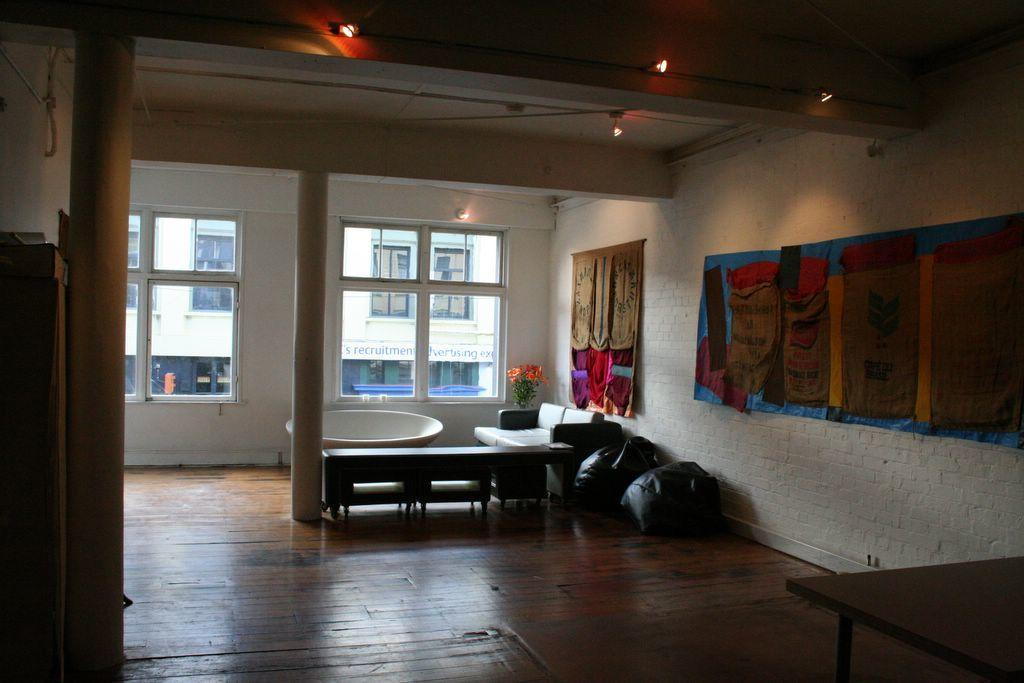What type of space is depicted in the image? The image shows an inner view of a room. What can be seen on the wall in the room? There is a poster on the wall. What type of seating is available in the room? There are bean bags and a sofa set in the room. Is there any greenery present in the room? Yes, there is a flower pot in the room. Can you tell me how many fingers are visible in the image? There are no fingers visible in the image; it shows an inner view of a room with various objects and furniture. 